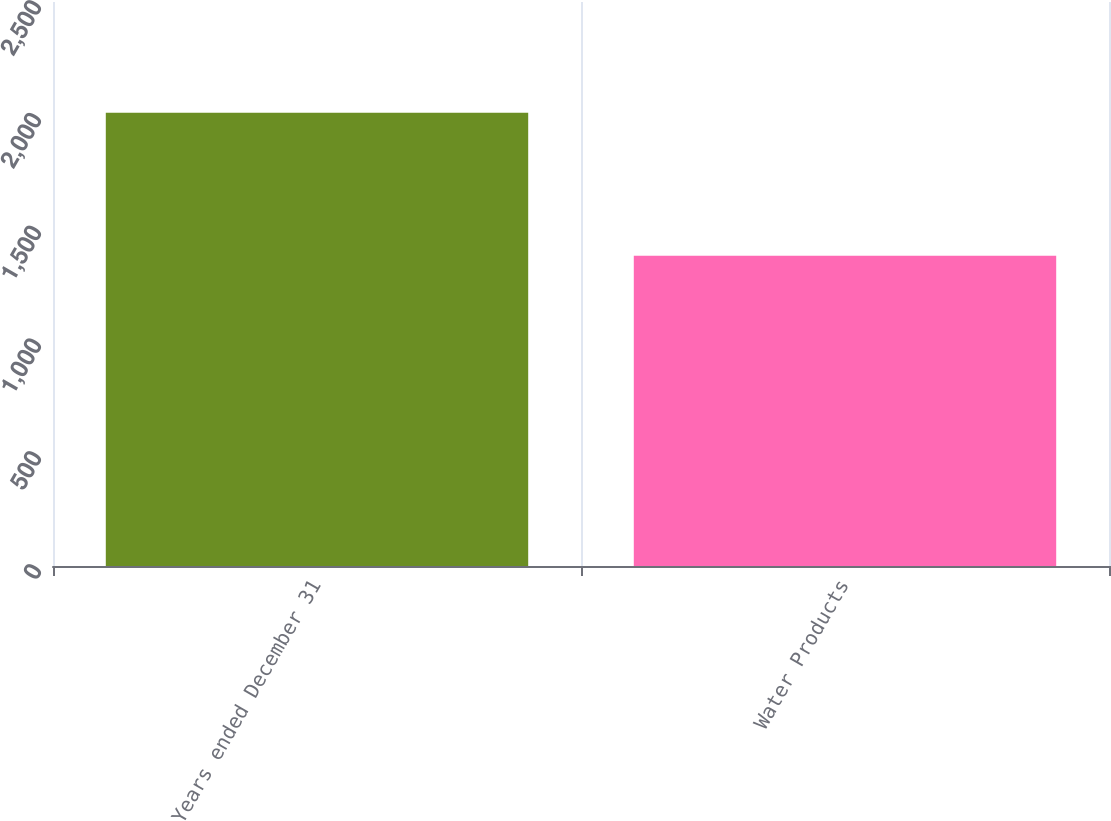<chart> <loc_0><loc_0><loc_500><loc_500><bar_chart><fcel>Years ended December 31<fcel>Water Products<nl><fcel>2009<fcel>1375<nl></chart> 